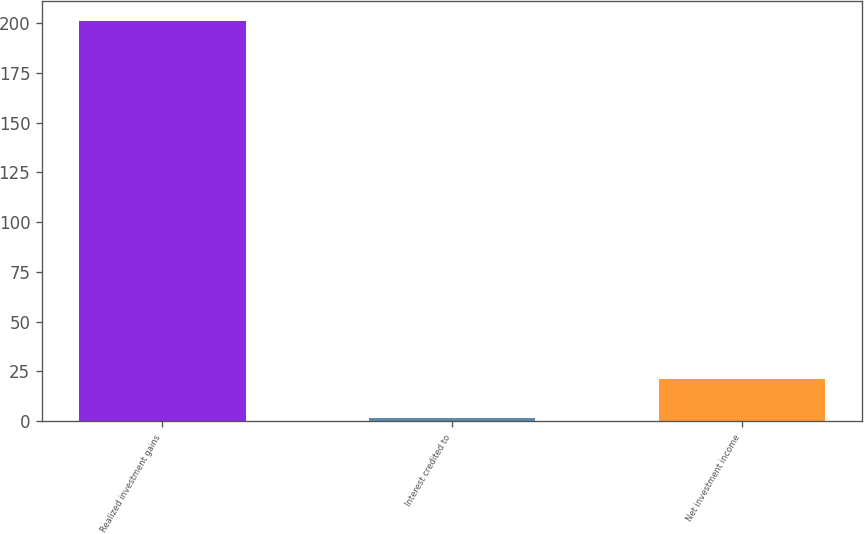Convert chart to OTSL. <chart><loc_0><loc_0><loc_500><loc_500><bar_chart><fcel>Realized investment gains<fcel>Interest credited to<fcel>Net investment income<nl><fcel>201<fcel>1.44<fcel>21.4<nl></chart> 